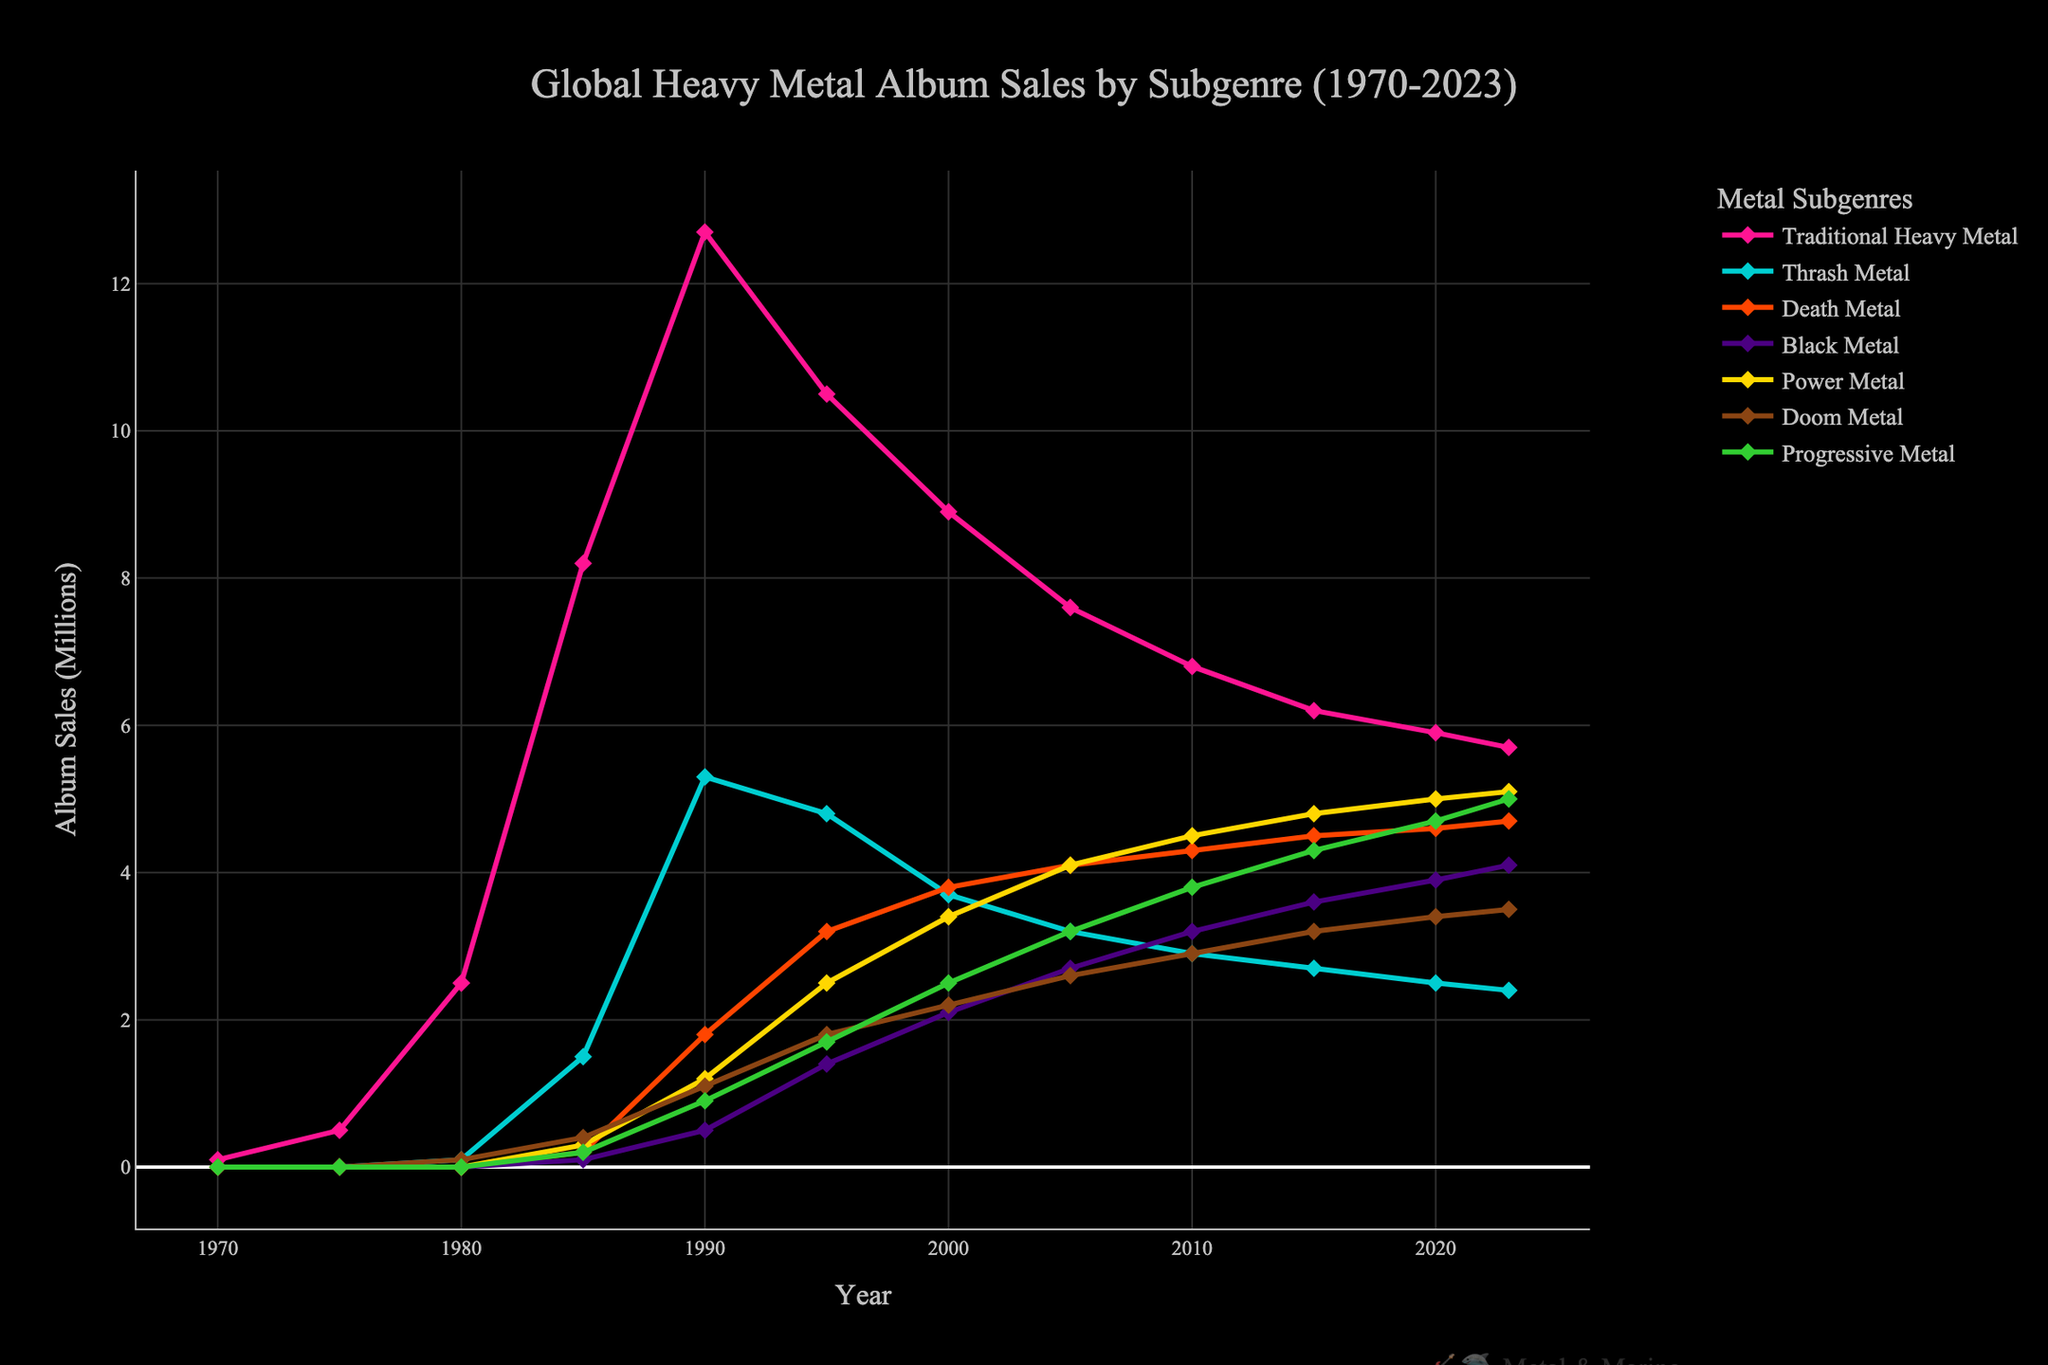What is the general trend in Global Heavy Metal Album Sales for Traditional Heavy Metal from 1970 to 2023? The sales of Traditional Heavy Metal albums started at 0.1 million in 1970, peaked at 12.7 million in 1990, and then generally declined, reaching 5.7 million in 2023. This suggests an initial rise followed by a gradual decline in sales.
Answer: Initial rise, then decline Which subgenre had the highest increase in album sales between 1970 and 2023? To determine the highest increase, we need to check each subgenre's sales in 1970 and 2023. Traditional Heavy Metal increased from 0.1 to 5.7 million (+5.6M), Thrash Metal increased from 0 to 2.4 million (+2.4M), Death Metal increased from 0 to 4.7 million (+4.7M), Black Metal increased from 0 to 4.1 million (+4.1M), Power Metal increased from 0 to 5.1 million (+5.1M), Doom Metal increased from 0 to 3.5 million (+3.5M), and Progressive Metal increased from 0 to 5 million (+5M). Therefore, Power Metal had the highest increase of 5.1 million.
Answer: Power Metal Which two subgenres were closest in album sales in the year 2000? Checking the values for the year 2000: Traditional Heavy Metal (8.9M), Thrash Metal (3.7M), Death Metal (3.8M), Black Metal (2.1M), Power Metal (3.4M), Doom Metal (2.2M), Progressive Metal (2.5M). The closest values are Thrash Metal (3.7M) and Death Metal (3.8M).
Answer: Thrash and Death Metal What is the difference in album sales between Death Metal and Black Metal in 2023? In 2023, Death Metal sales are 4.7 million and Black Metal sales are 4.1 million. The difference is 4.7 - 4.1 = 0.6 million.
Answer: 0.6 million How did the sales of Progressive Metal change from 1985 to 2023? In 1985, Progressive Metal sales were 0.2 million, and by 2023 they had increased to 5.0 million. The change is 5.0 - 0.2 = 4.8 million increase over the period.
Answer: Increased by 4.8 million Which subgenre had the most stable sales between 2000 and 2023? Review the data: Traditional Heavy Metal (from 8.9 to 5.7), Thrash Metal (from 3.7 to 2.4), Death Metal (from 3.8 to 4.7), Black Metal (from 2.1 to 4.1), Power Metal (from 3.4 to 5.1), Doom Metal (from 2.2 to 3.5), Progressive Metal (from 2.5 to 5.0). Death Metal had the smallest fluctuation (3.8 to 4.7), suggesting the most stability.
Answer: Death Metal Which subgenre had its peak album sales earliest? Looking at peak years and values: Traditional Heavy Metal peaked in 1990 (12.7M), Thrash Metal in 1990 (5.3M), Death Metal in 2023 (4.7M), Black Metal in 2023 (4.1M), Power Metal in 2023 (5.1M), Doom Metal in 2023 (3.5M), Progressive Metal in 2023 (5.0M). Traditional Heavy Metal and Thrash Metal peaked earliest in 1990.
Answer: Traditional Heavy Metal and Thrash Metal 